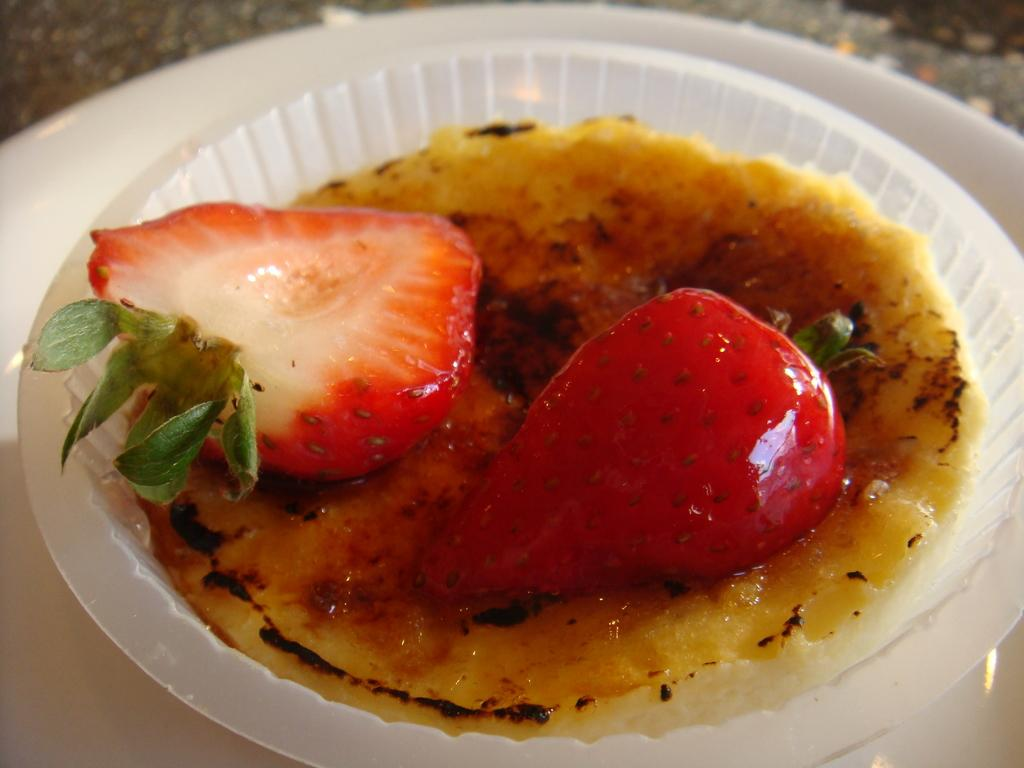What piece of furniture is present in the image? There is a table in the image. What is placed on the table? There is a plate on the table. What is on the plate? There is a bowl with a food item on the plate. What type of shoe can be seen in the image? There is no shoe present in the image. 